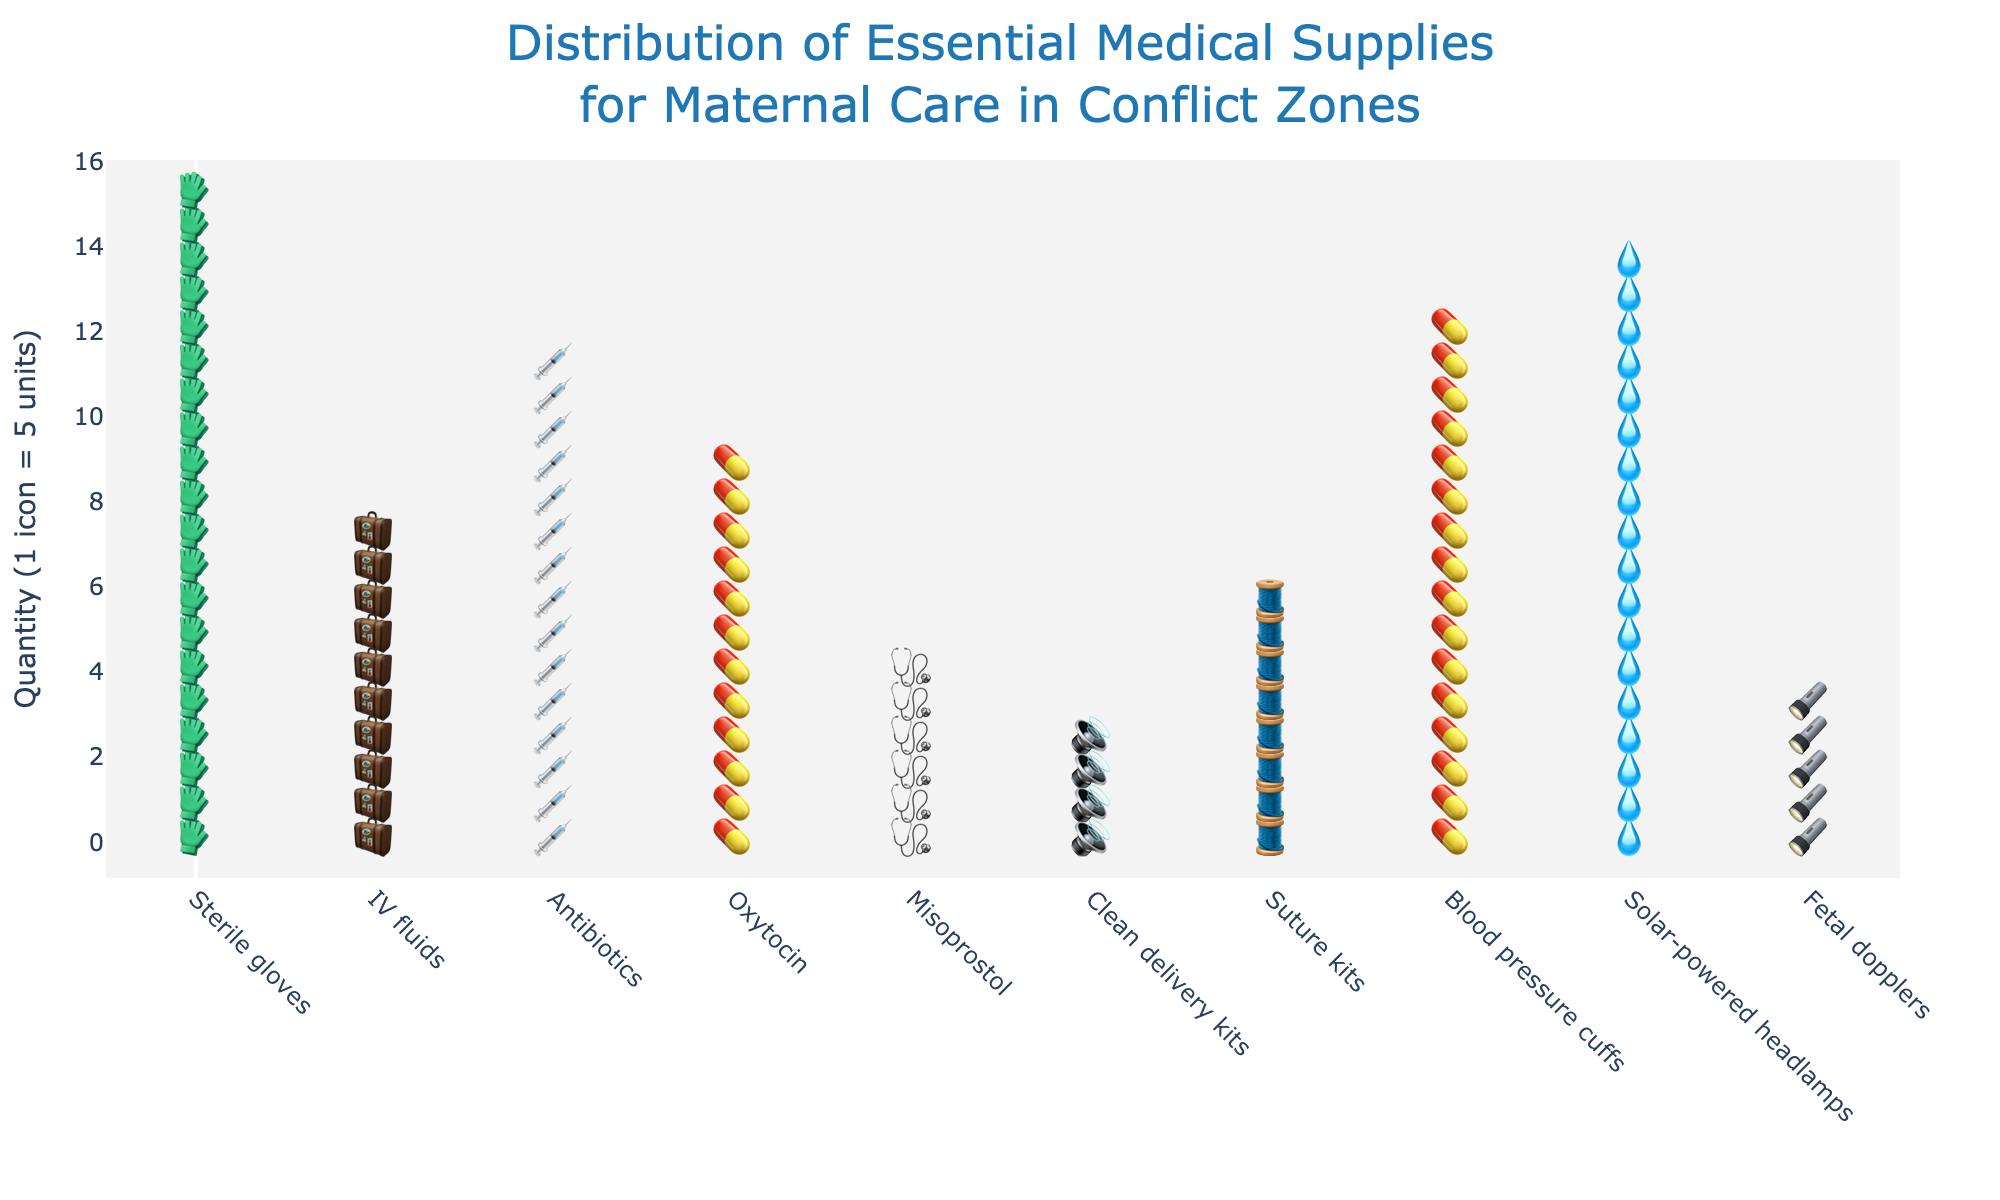What's the most frequently supplied item? The item that has the highest quantity is the most frequently supplied. By checking the plot, Sterile gloves have the largest number of icons.
Answer: Sterile gloves Which item has the fewest units supplied? The item with the smallest number of icons represents the fewest units supplied. Fetal dopplers have the fewest icons on the plot.
Answer: Fetal dopplers How many units of Oxytocin and Misoprostol are supplied in total? Adding the quantities of Oxytocin and Misoprostol together. Oxytocin has 75 units, and Misoprostol has 60 units. So, 75 + 60 = 135.
Answer: 135 units Which item is supplied in greater quantity, Clean delivery kits or Suture kits? Comparing the quantity of Clean delivery kits to Suture kits. Clean delivery kits have 50 units, while Suture kits have 40 units.
Answer: Clean delivery kits If each item should have at least 45 units, how many items do not meet this requirement? Identifying items with quantities less than 45 units. From the plot, Blood pressure cuffs have 30 units, Fetal dopplers have 20 units, Suture kits have 40 units, and Solar-powered headlamps have 25 units, making a total of 4 items not meeting the requirement.
Answer: 4 items What's the average quantity of Antibiotics and IV fluids supplied? Finding the average by summing the quantities of Antibiotics and IV fluids and then dividing by 2. Antibiotics have 80 units, IV fluids have 90 units. (80 + 90) / 2 = 85.
Answer: 85 units How many more units of Sterile gloves are supplied compared to Solar-powered headlamps? Subtracting the quantity of Solar-powered headlamps from the quantity of Sterile gloves. Sterile gloves have 100 units, and Solar-powered headlamps have 25 units. So, 100 - 25 = 75.
Answer: 75 units Which items have a quantity greater than 70 units? Identifying items with more than 70 units by examining the quantities. Sterile gloves (100), Oxytocin (75), Antibiotics (80), and IV fluids (90) are all greater than 70 units.
Answer: Sterile gloves, Oxytocin, Antibiotics, IV fluids How many icons represent the Antibiotics? Since one icon represents 5 units, dividing the quantity of Antibiotics by 5. Antibiotics have 80 units, so 80 / 5 = 16 icons.
Answer: 16 icons Which item is exactly halfway in terms of quantity distribution among all supplies? Sorting the quantities and finding the median. Sorting the quantities: [20, 25, 30, 40, 50, 60, 75, 80, 90, 100], Misoprostol, with 60 units, is the middle value in this sorted list.
Answer: Misoprostol 